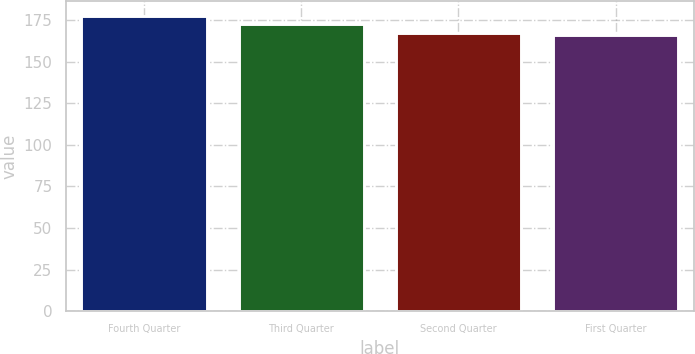<chart> <loc_0><loc_0><loc_500><loc_500><bar_chart><fcel>Fourth Quarter<fcel>Third Quarter<fcel>Second Quarter<fcel>First Quarter<nl><fcel>177.83<fcel>172.87<fcel>167.17<fcel>165.99<nl></chart> 